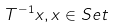Convert formula to latex. <formula><loc_0><loc_0><loc_500><loc_500>T ^ { - 1 } x , x \in S e t</formula> 